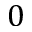Convert formula to latex. <formula><loc_0><loc_0><loc_500><loc_500>0</formula> 